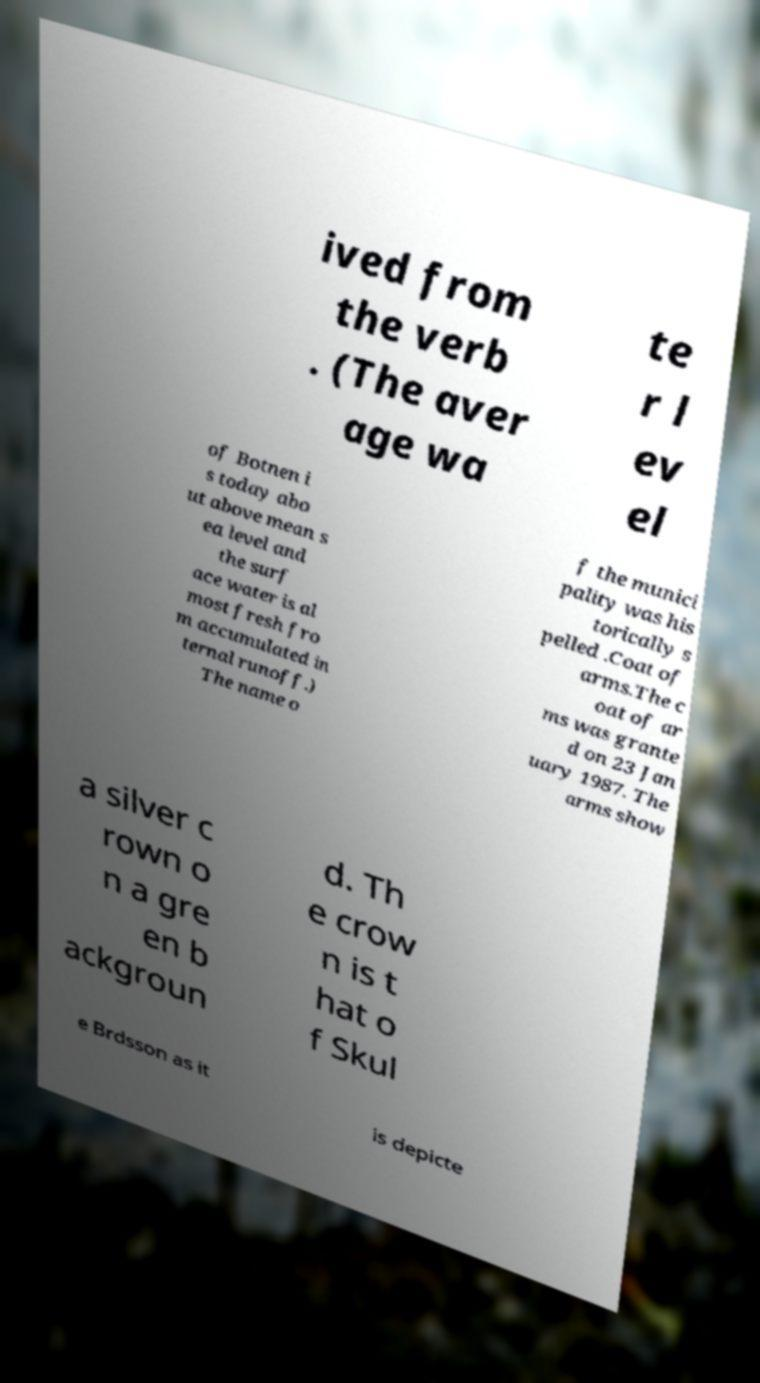Please identify and transcribe the text found in this image. ived from the verb . (The aver age wa te r l ev el of Botnen i s today abo ut above mean s ea level and the surf ace water is al most fresh fro m accumulated in ternal runoff.) The name o f the munici pality was his torically s pelled .Coat of arms.The c oat of ar ms was grante d on 23 Jan uary 1987. The arms show a silver c rown o n a gre en b ackgroun d. Th e crow n is t hat o f Skul e Brdsson as it is depicte 